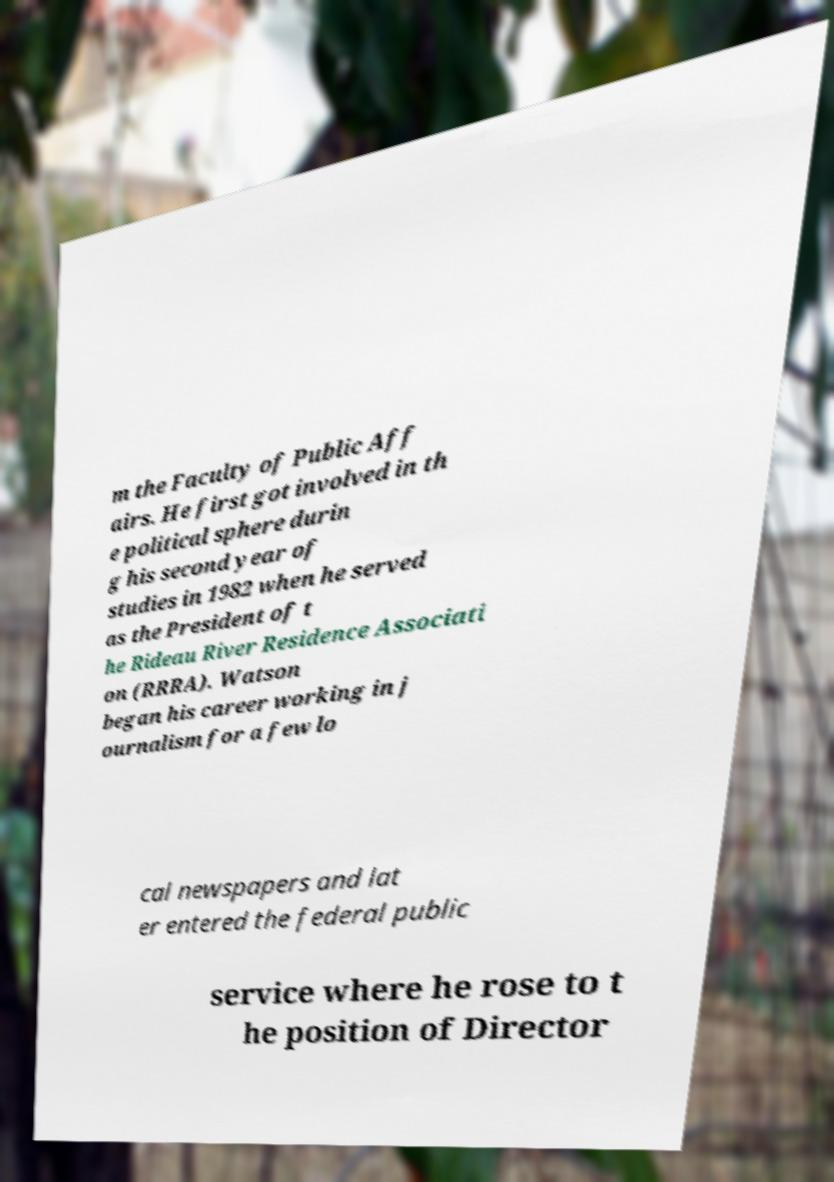I need the written content from this picture converted into text. Can you do that? m the Faculty of Public Aff airs. He first got involved in th e political sphere durin g his second year of studies in 1982 when he served as the President of t he Rideau River Residence Associati on (RRRA). Watson began his career working in j ournalism for a few lo cal newspapers and lat er entered the federal public service where he rose to t he position of Director 